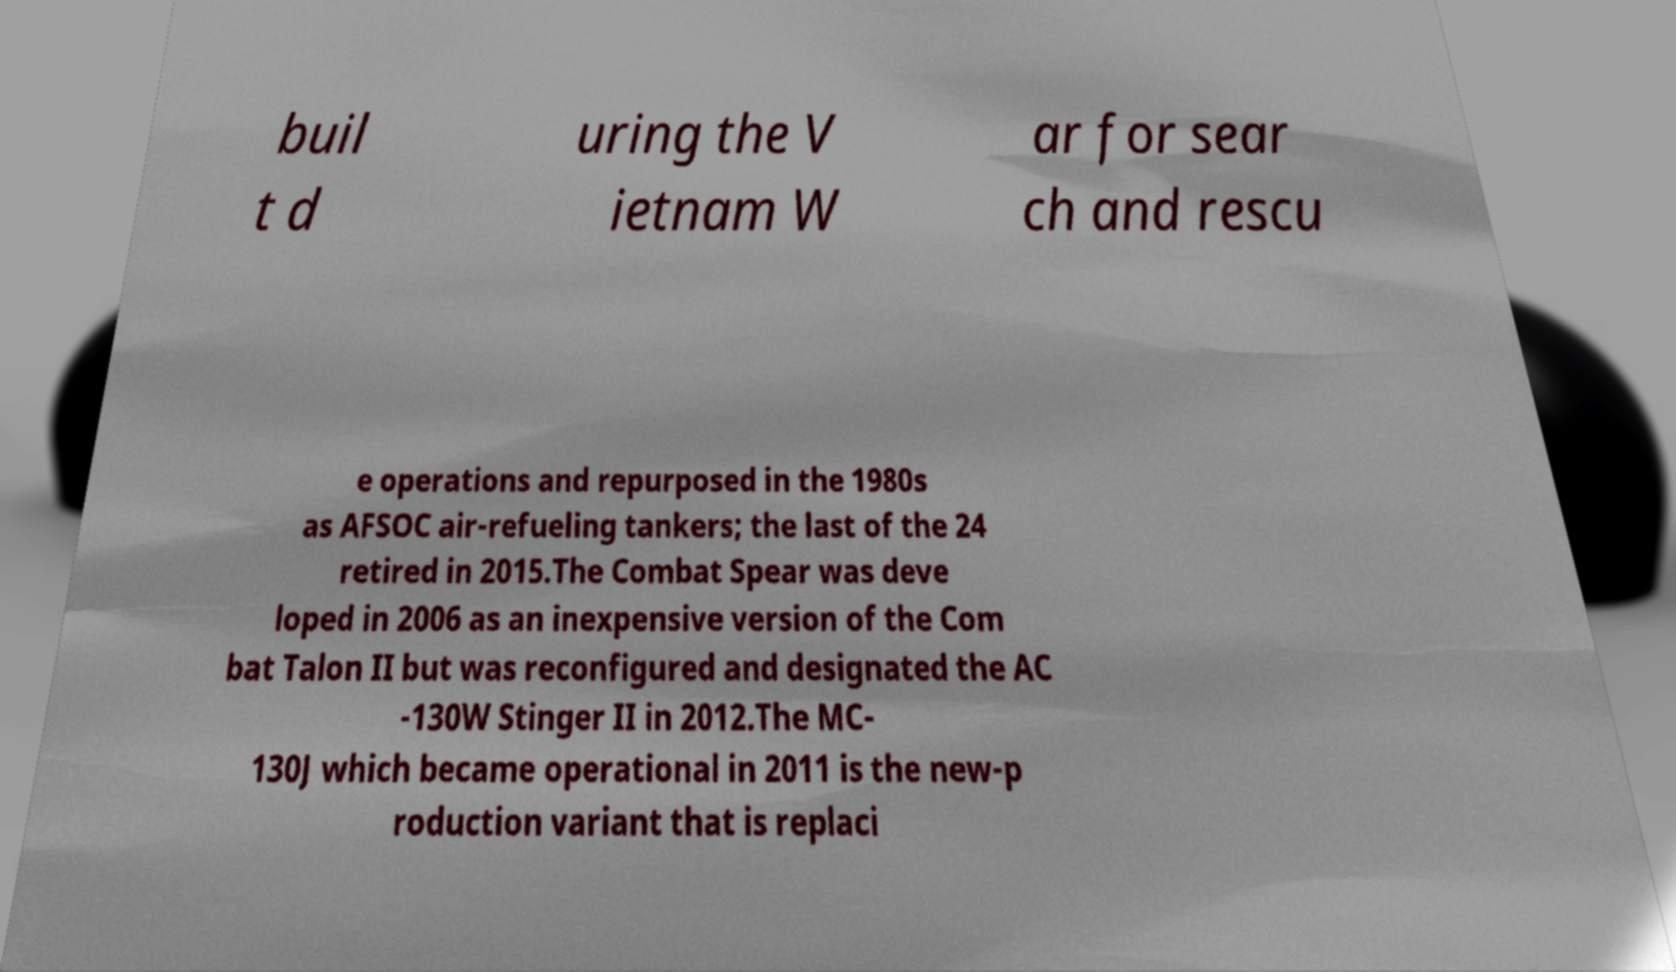For documentation purposes, I need the text within this image transcribed. Could you provide that? buil t d uring the V ietnam W ar for sear ch and rescu e operations and repurposed in the 1980s as AFSOC air-refueling tankers; the last of the 24 retired in 2015.The Combat Spear was deve loped in 2006 as an inexpensive version of the Com bat Talon II but was reconfigured and designated the AC -130W Stinger II in 2012.The MC- 130J which became operational in 2011 is the new-p roduction variant that is replaci 